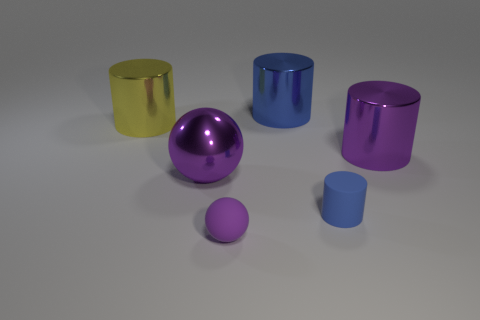Add 4 big brown rubber cubes. How many objects exist? 10 Subtract all balls. How many objects are left? 4 Add 4 small green shiny balls. How many small green shiny balls exist? 4 Subtract 0 green cylinders. How many objects are left? 6 Subtract all tiny purple rubber objects. Subtract all big things. How many objects are left? 1 Add 2 blue things. How many blue things are left? 4 